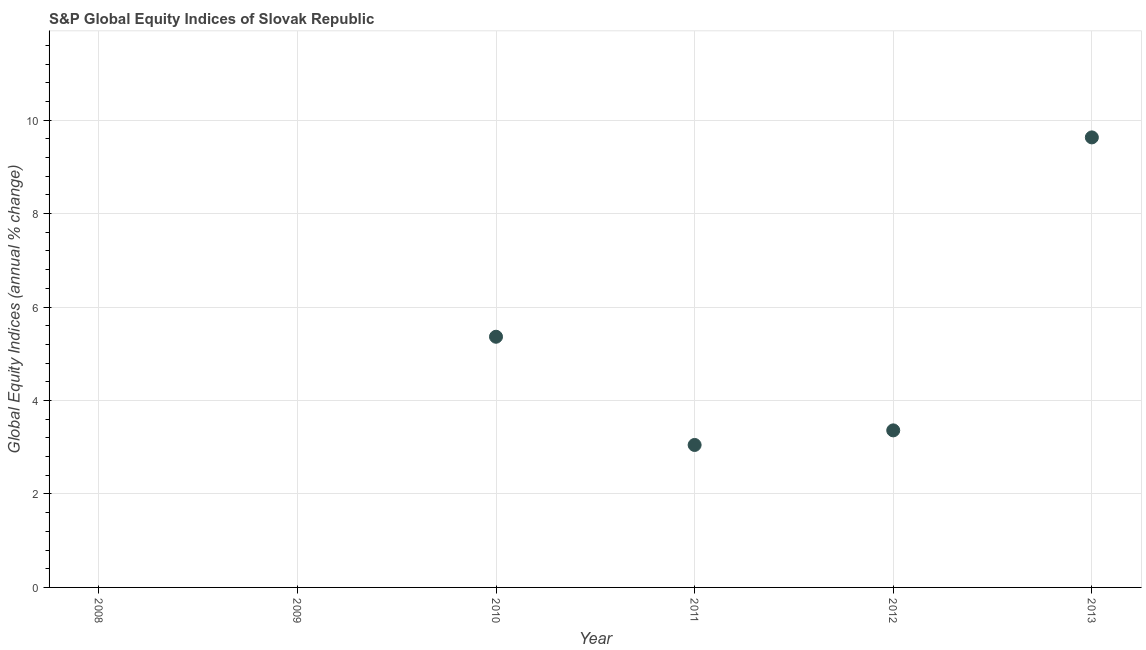What is the s&p global equity indices in 2009?
Offer a terse response. 0. Across all years, what is the maximum s&p global equity indices?
Offer a terse response. 9.63. Across all years, what is the minimum s&p global equity indices?
Your answer should be very brief. 0. In which year was the s&p global equity indices maximum?
Ensure brevity in your answer.  2013. What is the sum of the s&p global equity indices?
Give a very brief answer. 21.41. What is the difference between the s&p global equity indices in 2011 and 2013?
Your response must be concise. -6.58. What is the average s&p global equity indices per year?
Make the answer very short. 3.57. What is the median s&p global equity indices?
Give a very brief answer. 3.21. In how many years, is the s&p global equity indices greater than 7.6 %?
Make the answer very short. 1. What is the ratio of the s&p global equity indices in 2012 to that in 2013?
Your answer should be very brief. 0.35. Is the s&p global equity indices in 2012 less than that in 2013?
Provide a succinct answer. Yes. What is the difference between the highest and the second highest s&p global equity indices?
Offer a terse response. 4.27. Is the sum of the s&p global equity indices in 2012 and 2013 greater than the maximum s&p global equity indices across all years?
Provide a short and direct response. Yes. What is the difference between the highest and the lowest s&p global equity indices?
Your answer should be compact. 9.63. How many dotlines are there?
Your response must be concise. 1. What is the title of the graph?
Keep it short and to the point. S&P Global Equity Indices of Slovak Republic. What is the label or title of the X-axis?
Offer a terse response. Year. What is the label or title of the Y-axis?
Offer a terse response. Global Equity Indices (annual % change). What is the Global Equity Indices (annual % change) in 2009?
Your answer should be very brief. 0. What is the Global Equity Indices (annual % change) in 2010?
Offer a very short reply. 5.36. What is the Global Equity Indices (annual % change) in 2011?
Make the answer very short. 3.05. What is the Global Equity Indices (annual % change) in 2012?
Give a very brief answer. 3.36. What is the Global Equity Indices (annual % change) in 2013?
Make the answer very short. 9.63. What is the difference between the Global Equity Indices (annual % change) in 2010 and 2011?
Your response must be concise. 2.32. What is the difference between the Global Equity Indices (annual % change) in 2010 and 2012?
Give a very brief answer. 2. What is the difference between the Global Equity Indices (annual % change) in 2010 and 2013?
Give a very brief answer. -4.27. What is the difference between the Global Equity Indices (annual % change) in 2011 and 2012?
Make the answer very short. -0.31. What is the difference between the Global Equity Indices (annual % change) in 2011 and 2013?
Your response must be concise. -6.58. What is the difference between the Global Equity Indices (annual % change) in 2012 and 2013?
Give a very brief answer. -6.27. What is the ratio of the Global Equity Indices (annual % change) in 2010 to that in 2011?
Provide a short and direct response. 1.76. What is the ratio of the Global Equity Indices (annual % change) in 2010 to that in 2012?
Provide a succinct answer. 1.6. What is the ratio of the Global Equity Indices (annual % change) in 2010 to that in 2013?
Offer a terse response. 0.56. What is the ratio of the Global Equity Indices (annual % change) in 2011 to that in 2012?
Offer a very short reply. 0.91. What is the ratio of the Global Equity Indices (annual % change) in 2011 to that in 2013?
Offer a terse response. 0.32. What is the ratio of the Global Equity Indices (annual % change) in 2012 to that in 2013?
Your answer should be compact. 0.35. 